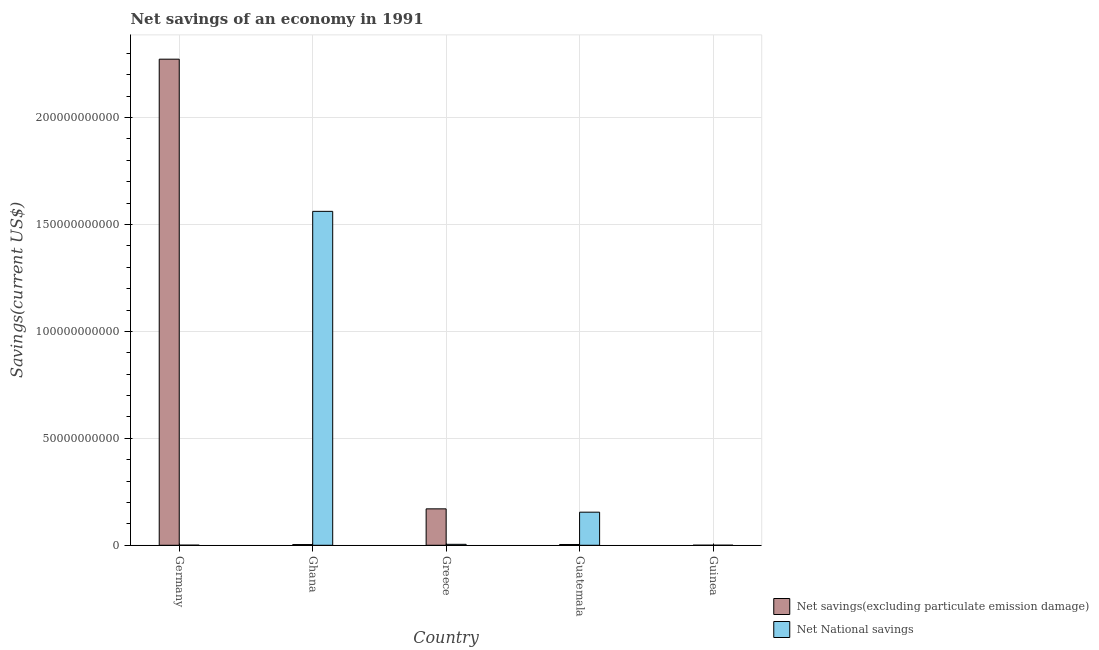Are the number of bars on each tick of the X-axis equal?
Provide a succinct answer. Yes. How many bars are there on the 5th tick from the left?
Your answer should be very brief. 2. What is the label of the 3rd group of bars from the left?
Your response must be concise. Greece. What is the net savings(excluding particulate emission damage) in Ghana?
Make the answer very short. 3.35e+08. Across all countries, what is the maximum net national savings?
Your answer should be very brief. 1.56e+11. Across all countries, what is the minimum net national savings?
Give a very brief answer. 3.05e+07. In which country was the net savings(excluding particulate emission damage) maximum?
Ensure brevity in your answer.  Germany. In which country was the net savings(excluding particulate emission damage) minimum?
Provide a succinct answer. Guinea. What is the total net savings(excluding particulate emission damage) in the graph?
Provide a succinct answer. 2.45e+11. What is the difference between the net savings(excluding particulate emission damage) in Germany and that in Greece?
Provide a succinct answer. 2.10e+11. What is the difference between the net savings(excluding particulate emission damage) in Ghana and the net national savings in Guatemala?
Provide a succinct answer. -1.51e+1. What is the average net savings(excluding particulate emission damage) per country?
Your answer should be compact. 4.90e+1. What is the difference between the net national savings and net savings(excluding particulate emission damage) in Greece?
Provide a short and direct response. -1.66e+1. In how many countries, is the net national savings greater than 30000000000 US$?
Keep it short and to the point. 1. What is the ratio of the net national savings in Germany to that in Guinea?
Offer a very short reply. 1.74. Is the net savings(excluding particulate emission damage) in Germany less than that in Guatemala?
Offer a terse response. No. What is the difference between the highest and the second highest net national savings?
Ensure brevity in your answer.  1.41e+11. What is the difference between the highest and the lowest net national savings?
Keep it short and to the point. 1.56e+11. Is the sum of the net savings(excluding particulate emission damage) in Germany and Guatemala greater than the maximum net national savings across all countries?
Provide a succinct answer. Yes. What does the 2nd bar from the left in Guinea represents?
Keep it short and to the point. Net National savings. What does the 1st bar from the right in Germany represents?
Make the answer very short. Net National savings. How many countries are there in the graph?
Give a very brief answer. 5. What is the difference between two consecutive major ticks on the Y-axis?
Offer a terse response. 5.00e+1. Are the values on the major ticks of Y-axis written in scientific E-notation?
Keep it short and to the point. No. Does the graph contain any zero values?
Your answer should be very brief. No. Does the graph contain grids?
Offer a terse response. Yes. What is the title of the graph?
Give a very brief answer. Net savings of an economy in 1991. Does "Nonresident" appear as one of the legend labels in the graph?
Give a very brief answer. No. What is the label or title of the Y-axis?
Make the answer very short. Savings(current US$). What is the Savings(current US$) in Net savings(excluding particulate emission damage) in Germany?
Offer a terse response. 2.27e+11. What is the Savings(current US$) in Net National savings in Germany?
Keep it short and to the point. 5.29e+07. What is the Savings(current US$) of Net savings(excluding particulate emission damage) in Ghana?
Provide a succinct answer. 3.35e+08. What is the Savings(current US$) in Net National savings in Ghana?
Offer a terse response. 1.56e+11. What is the Savings(current US$) of Net savings(excluding particulate emission damage) in Greece?
Your answer should be very brief. 1.70e+1. What is the Savings(current US$) in Net National savings in Greece?
Offer a very short reply. 4.47e+08. What is the Savings(current US$) of Net savings(excluding particulate emission damage) in Guatemala?
Your answer should be compact. 3.66e+08. What is the Savings(current US$) of Net National savings in Guatemala?
Ensure brevity in your answer.  1.55e+1. What is the Savings(current US$) in Net savings(excluding particulate emission damage) in Guinea?
Give a very brief answer. 3.30e+07. What is the Savings(current US$) in Net National savings in Guinea?
Provide a succinct answer. 3.05e+07. Across all countries, what is the maximum Savings(current US$) of Net savings(excluding particulate emission damage)?
Ensure brevity in your answer.  2.27e+11. Across all countries, what is the maximum Savings(current US$) in Net National savings?
Your answer should be very brief. 1.56e+11. Across all countries, what is the minimum Savings(current US$) of Net savings(excluding particulate emission damage)?
Make the answer very short. 3.30e+07. Across all countries, what is the minimum Savings(current US$) of Net National savings?
Keep it short and to the point. 3.05e+07. What is the total Savings(current US$) in Net savings(excluding particulate emission damage) in the graph?
Provide a short and direct response. 2.45e+11. What is the total Savings(current US$) in Net National savings in the graph?
Your answer should be very brief. 1.72e+11. What is the difference between the Savings(current US$) in Net savings(excluding particulate emission damage) in Germany and that in Ghana?
Your response must be concise. 2.27e+11. What is the difference between the Savings(current US$) of Net National savings in Germany and that in Ghana?
Offer a terse response. -1.56e+11. What is the difference between the Savings(current US$) in Net savings(excluding particulate emission damage) in Germany and that in Greece?
Your answer should be very brief. 2.10e+11. What is the difference between the Savings(current US$) of Net National savings in Germany and that in Greece?
Give a very brief answer. -3.94e+08. What is the difference between the Savings(current US$) of Net savings(excluding particulate emission damage) in Germany and that in Guatemala?
Offer a terse response. 2.27e+11. What is the difference between the Savings(current US$) of Net National savings in Germany and that in Guatemala?
Ensure brevity in your answer.  -1.54e+1. What is the difference between the Savings(current US$) of Net savings(excluding particulate emission damage) in Germany and that in Guinea?
Give a very brief answer. 2.27e+11. What is the difference between the Savings(current US$) of Net National savings in Germany and that in Guinea?
Your response must be concise. 2.24e+07. What is the difference between the Savings(current US$) in Net savings(excluding particulate emission damage) in Ghana and that in Greece?
Make the answer very short. -1.67e+1. What is the difference between the Savings(current US$) in Net National savings in Ghana and that in Greece?
Ensure brevity in your answer.  1.56e+11. What is the difference between the Savings(current US$) in Net savings(excluding particulate emission damage) in Ghana and that in Guatemala?
Your answer should be compact. -3.10e+07. What is the difference between the Savings(current US$) of Net National savings in Ghana and that in Guatemala?
Offer a very short reply. 1.41e+11. What is the difference between the Savings(current US$) in Net savings(excluding particulate emission damage) in Ghana and that in Guinea?
Keep it short and to the point. 3.02e+08. What is the difference between the Savings(current US$) in Net National savings in Ghana and that in Guinea?
Provide a short and direct response. 1.56e+11. What is the difference between the Savings(current US$) of Net savings(excluding particulate emission damage) in Greece and that in Guatemala?
Keep it short and to the point. 1.67e+1. What is the difference between the Savings(current US$) in Net National savings in Greece and that in Guatemala?
Provide a succinct answer. -1.50e+1. What is the difference between the Savings(current US$) of Net savings(excluding particulate emission damage) in Greece and that in Guinea?
Offer a very short reply. 1.70e+1. What is the difference between the Savings(current US$) of Net National savings in Greece and that in Guinea?
Provide a succinct answer. 4.16e+08. What is the difference between the Savings(current US$) in Net savings(excluding particulate emission damage) in Guatemala and that in Guinea?
Make the answer very short. 3.33e+08. What is the difference between the Savings(current US$) in Net National savings in Guatemala and that in Guinea?
Give a very brief answer. 1.54e+1. What is the difference between the Savings(current US$) of Net savings(excluding particulate emission damage) in Germany and the Savings(current US$) of Net National savings in Ghana?
Your response must be concise. 7.12e+1. What is the difference between the Savings(current US$) of Net savings(excluding particulate emission damage) in Germany and the Savings(current US$) of Net National savings in Greece?
Your answer should be compact. 2.27e+11. What is the difference between the Savings(current US$) in Net savings(excluding particulate emission damage) in Germany and the Savings(current US$) in Net National savings in Guatemala?
Give a very brief answer. 2.12e+11. What is the difference between the Savings(current US$) in Net savings(excluding particulate emission damage) in Germany and the Savings(current US$) in Net National savings in Guinea?
Your answer should be compact. 2.27e+11. What is the difference between the Savings(current US$) in Net savings(excluding particulate emission damage) in Ghana and the Savings(current US$) in Net National savings in Greece?
Offer a terse response. -1.11e+08. What is the difference between the Savings(current US$) of Net savings(excluding particulate emission damage) in Ghana and the Savings(current US$) of Net National savings in Guatemala?
Your response must be concise. -1.51e+1. What is the difference between the Savings(current US$) of Net savings(excluding particulate emission damage) in Ghana and the Savings(current US$) of Net National savings in Guinea?
Your response must be concise. 3.05e+08. What is the difference between the Savings(current US$) of Net savings(excluding particulate emission damage) in Greece and the Savings(current US$) of Net National savings in Guatemala?
Ensure brevity in your answer.  1.56e+09. What is the difference between the Savings(current US$) of Net savings(excluding particulate emission damage) in Greece and the Savings(current US$) of Net National savings in Guinea?
Make the answer very short. 1.70e+1. What is the difference between the Savings(current US$) of Net savings(excluding particulate emission damage) in Guatemala and the Savings(current US$) of Net National savings in Guinea?
Provide a short and direct response. 3.36e+08. What is the average Savings(current US$) of Net savings(excluding particulate emission damage) per country?
Give a very brief answer. 4.90e+1. What is the average Savings(current US$) in Net National savings per country?
Ensure brevity in your answer.  3.44e+1. What is the difference between the Savings(current US$) in Net savings(excluding particulate emission damage) and Savings(current US$) in Net National savings in Germany?
Offer a terse response. 2.27e+11. What is the difference between the Savings(current US$) in Net savings(excluding particulate emission damage) and Savings(current US$) in Net National savings in Ghana?
Your answer should be compact. -1.56e+11. What is the difference between the Savings(current US$) of Net savings(excluding particulate emission damage) and Savings(current US$) of Net National savings in Greece?
Keep it short and to the point. 1.66e+1. What is the difference between the Savings(current US$) of Net savings(excluding particulate emission damage) and Savings(current US$) of Net National savings in Guatemala?
Your answer should be very brief. -1.51e+1. What is the difference between the Savings(current US$) in Net savings(excluding particulate emission damage) and Savings(current US$) in Net National savings in Guinea?
Provide a short and direct response. 2.57e+06. What is the ratio of the Savings(current US$) of Net savings(excluding particulate emission damage) in Germany to that in Ghana?
Offer a very short reply. 677.63. What is the ratio of the Savings(current US$) in Net National savings in Germany to that in Ghana?
Ensure brevity in your answer.  0. What is the ratio of the Savings(current US$) of Net savings(excluding particulate emission damage) in Germany to that in Greece?
Provide a succinct answer. 13.34. What is the ratio of the Savings(current US$) in Net National savings in Germany to that in Greece?
Keep it short and to the point. 0.12. What is the ratio of the Savings(current US$) of Net savings(excluding particulate emission damage) in Germany to that in Guatemala?
Offer a very short reply. 620.39. What is the ratio of the Savings(current US$) of Net National savings in Germany to that in Guatemala?
Provide a succinct answer. 0. What is the ratio of the Savings(current US$) in Net savings(excluding particulate emission damage) in Germany to that in Guinea?
Your response must be concise. 6878.89. What is the ratio of the Savings(current US$) in Net National savings in Germany to that in Guinea?
Provide a short and direct response. 1.74. What is the ratio of the Savings(current US$) in Net savings(excluding particulate emission damage) in Ghana to that in Greece?
Give a very brief answer. 0.02. What is the ratio of the Savings(current US$) in Net National savings in Ghana to that in Greece?
Provide a short and direct response. 349.56. What is the ratio of the Savings(current US$) in Net savings(excluding particulate emission damage) in Ghana to that in Guatemala?
Make the answer very short. 0.92. What is the ratio of the Savings(current US$) in Net National savings in Ghana to that in Guatemala?
Keep it short and to the point. 10.09. What is the ratio of the Savings(current US$) of Net savings(excluding particulate emission damage) in Ghana to that in Guinea?
Keep it short and to the point. 10.15. What is the ratio of the Savings(current US$) of Net National savings in Ghana to that in Guinea?
Offer a terse response. 5123.73. What is the ratio of the Savings(current US$) of Net savings(excluding particulate emission damage) in Greece to that in Guatemala?
Provide a short and direct response. 46.49. What is the ratio of the Savings(current US$) in Net National savings in Greece to that in Guatemala?
Provide a short and direct response. 0.03. What is the ratio of the Savings(current US$) of Net savings(excluding particulate emission damage) in Greece to that in Guinea?
Your answer should be compact. 515.48. What is the ratio of the Savings(current US$) of Net National savings in Greece to that in Guinea?
Offer a terse response. 14.66. What is the ratio of the Savings(current US$) in Net savings(excluding particulate emission damage) in Guatemala to that in Guinea?
Offer a very short reply. 11.09. What is the ratio of the Savings(current US$) in Net National savings in Guatemala to that in Guinea?
Give a very brief answer. 507.74. What is the difference between the highest and the second highest Savings(current US$) of Net savings(excluding particulate emission damage)?
Make the answer very short. 2.10e+11. What is the difference between the highest and the second highest Savings(current US$) in Net National savings?
Your response must be concise. 1.41e+11. What is the difference between the highest and the lowest Savings(current US$) of Net savings(excluding particulate emission damage)?
Your answer should be very brief. 2.27e+11. What is the difference between the highest and the lowest Savings(current US$) of Net National savings?
Make the answer very short. 1.56e+11. 